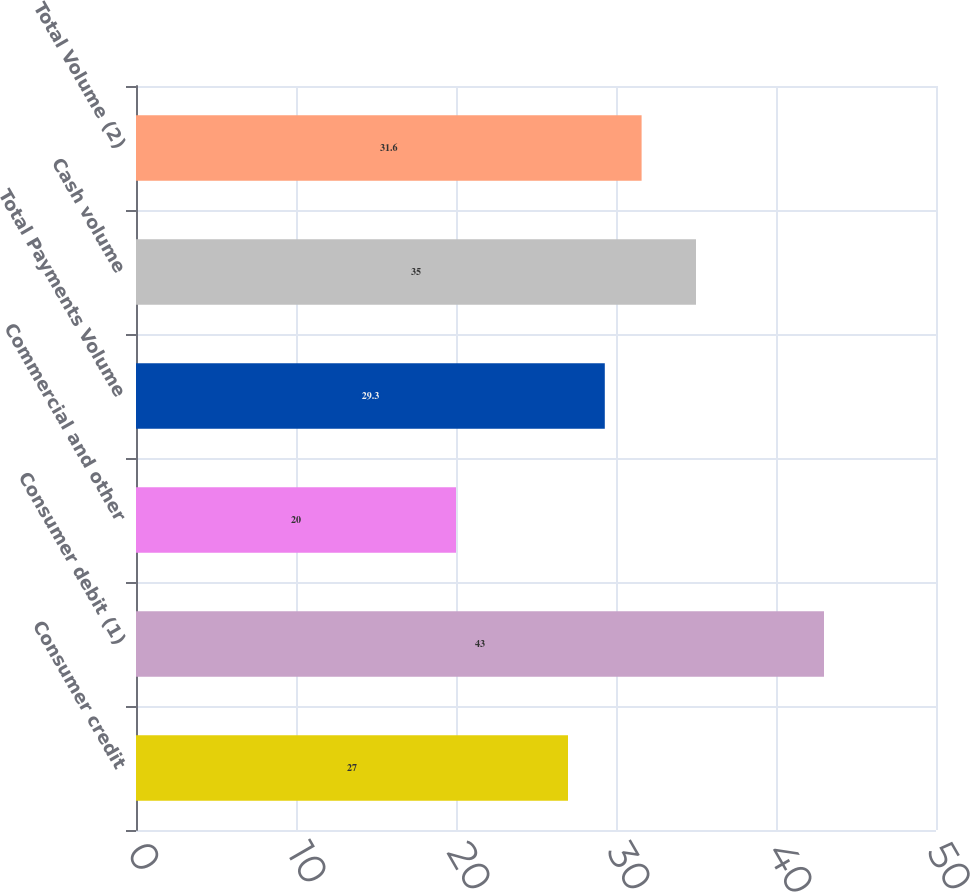Convert chart. <chart><loc_0><loc_0><loc_500><loc_500><bar_chart><fcel>Consumer credit<fcel>Consumer debit (1)<fcel>Commercial and other<fcel>Total Payments Volume<fcel>Cash volume<fcel>Total Volume (2)<nl><fcel>27<fcel>43<fcel>20<fcel>29.3<fcel>35<fcel>31.6<nl></chart> 